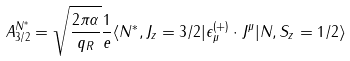Convert formula to latex. <formula><loc_0><loc_0><loc_500><loc_500>A _ { 3 / 2 } ^ { N ^ { \ast } } = \sqrt { \frac { 2 \pi \alpha } { q _ { R } } } \frac { 1 } { e } \langle N ^ { \ast } , J _ { z } = 3 / 2 | \epsilon _ { \mu } ^ { ( + ) } \cdot J ^ { \mu } | N , S _ { z } = 1 / 2 \rangle</formula> 